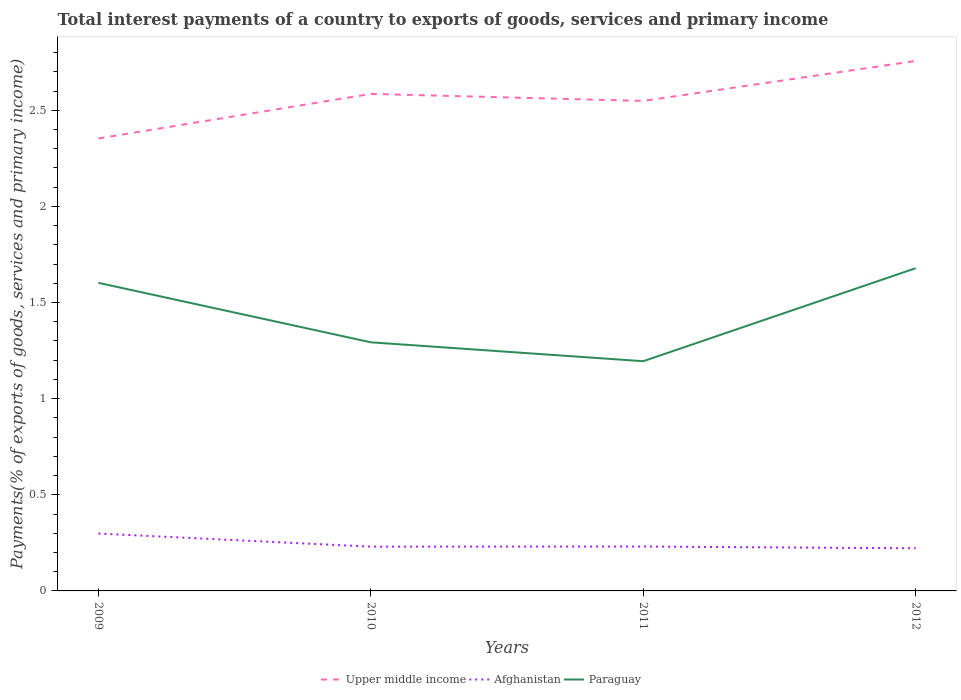Does the line corresponding to Afghanistan intersect with the line corresponding to Upper middle income?
Provide a succinct answer. No. Across all years, what is the maximum total interest payments in Paraguay?
Provide a succinct answer. 1.19. In which year was the total interest payments in Afghanistan maximum?
Provide a succinct answer. 2012. What is the total total interest payments in Upper middle income in the graph?
Provide a succinct answer. -0.17. What is the difference between the highest and the second highest total interest payments in Paraguay?
Your answer should be compact. 0.48. Is the total interest payments in Paraguay strictly greater than the total interest payments in Afghanistan over the years?
Your response must be concise. No. How many lines are there?
Ensure brevity in your answer.  3. What is the difference between two consecutive major ticks on the Y-axis?
Provide a succinct answer. 0.5. Are the values on the major ticks of Y-axis written in scientific E-notation?
Offer a very short reply. No. How are the legend labels stacked?
Your answer should be very brief. Horizontal. What is the title of the graph?
Provide a succinct answer. Total interest payments of a country to exports of goods, services and primary income. What is the label or title of the Y-axis?
Provide a short and direct response. Payments(% of exports of goods, services and primary income). What is the Payments(% of exports of goods, services and primary income) of Upper middle income in 2009?
Give a very brief answer. 2.35. What is the Payments(% of exports of goods, services and primary income) in Afghanistan in 2009?
Offer a terse response. 0.3. What is the Payments(% of exports of goods, services and primary income) of Paraguay in 2009?
Your response must be concise. 1.6. What is the Payments(% of exports of goods, services and primary income) in Upper middle income in 2010?
Offer a terse response. 2.59. What is the Payments(% of exports of goods, services and primary income) of Afghanistan in 2010?
Provide a succinct answer. 0.23. What is the Payments(% of exports of goods, services and primary income) of Paraguay in 2010?
Provide a succinct answer. 1.29. What is the Payments(% of exports of goods, services and primary income) in Upper middle income in 2011?
Ensure brevity in your answer.  2.55. What is the Payments(% of exports of goods, services and primary income) in Afghanistan in 2011?
Provide a succinct answer. 0.23. What is the Payments(% of exports of goods, services and primary income) in Paraguay in 2011?
Make the answer very short. 1.19. What is the Payments(% of exports of goods, services and primary income) of Upper middle income in 2012?
Provide a short and direct response. 2.76. What is the Payments(% of exports of goods, services and primary income) in Afghanistan in 2012?
Your answer should be very brief. 0.22. What is the Payments(% of exports of goods, services and primary income) of Paraguay in 2012?
Provide a short and direct response. 1.68. Across all years, what is the maximum Payments(% of exports of goods, services and primary income) of Upper middle income?
Offer a terse response. 2.76. Across all years, what is the maximum Payments(% of exports of goods, services and primary income) in Afghanistan?
Provide a short and direct response. 0.3. Across all years, what is the maximum Payments(% of exports of goods, services and primary income) in Paraguay?
Provide a succinct answer. 1.68. Across all years, what is the minimum Payments(% of exports of goods, services and primary income) in Upper middle income?
Your answer should be very brief. 2.35. Across all years, what is the minimum Payments(% of exports of goods, services and primary income) of Afghanistan?
Keep it short and to the point. 0.22. Across all years, what is the minimum Payments(% of exports of goods, services and primary income) in Paraguay?
Provide a succinct answer. 1.19. What is the total Payments(% of exports of goods, services and primary income) of Upper middle income in the graph?
Offer a terse response. 10.24. What is the total Payments(% of exports of goods, services and primary income) in Afghanistan in the graph?
Ensure brevity in your answer.  0.98. What is the total Payments(% of exports of goods, services and primary income) in Paraguay in the graph?
Your answer should be very brief. 5.77. What is the difference between the Payments(% of exports of goods, services and primary income) of Upper middle income in 2009 and that in 2010?
Provide a short and direct response. -0.23. What is the difference between the Payments(% of exports of goods, services and primary income) in Afghanistan in 2009 and that in 2010?
Offer a very short reply. 0.07. What is the difference between the Payments(% of exports of goods, services and primary income) of Paraguay in 2009 and that in 2010?
Offer a terse response. 0.31. What is the difference between the Payments(% of exports of goods, services and primary income) in Upper middle income in 2009 and that in 2011?
Offer a very short reply. -0.2. What is the difference between the Payments(% of exports of goods, services and primary income) of Afghanistan in 2009 and that in 2011?
Your answer should be compact. 0.07. What is the difference between the Payments(% of exports of goods, services and primary income) in Paraguay in 2009 and that in 2011?
Make the answer very short. 0.41. What is the difference between the Payments(% of exports of goods, services and primary income) in Upper middle income in 2009 and that in 2012?
Give a very brief answer. -0.4. What is the difference between the Payments(% of exports of goods, services and primary income) of Afghanistan in 2009 and that in 2012?
Make the answer very short. 0.08. What is the difference between the Payments(% of exports of goods, services and primary income) in Paraguay in 2009 and that in 2012?
Your answer should be compact. -0.08. What is the difference between the Payments(% of exports of goods, services and primary income) in Upper middle income in 2010 and that in 2011?
Make the answer very short. 0.04. What is the difference between the Payments(% of exports of goods, services and primary income) of Afghanistan in 2010 and that in 2011?
Offer a terse response. -0. What is the difference between the Payments(% of exports of goods, services and primary income) in Paraguay in 2010 and that in 2011?
Offer a terse response. 0.1. What is the difference between the Payments(% of exports of goods, services and primary income) of Upper middle income in 2010 and that in 2012?
Provide a succinct answer. -0.17. What is the difference between the Payments(% of exports of goods, services and primary income) in Afghanistan in 2010 and that in 2012?
Your response must be concise. 0.01. What is the difference between the Payments(% of exports of goods, services and primary income) of Paraguay in 2010 and that in 2012?
Your response must be concise. -0.39. What is the difference between the Payments(% of exports of goods, services and primary income) of Upper middle income in 2011 and that in 2012?
Provide a short and direct response. -0.21. What is the difference between the Payments(% of exports of goods, services and primary income) in Afghanistan in 2011 and that in 2012?
Offer a very short reply. 0.01. What is the difference between the Payments(% of exports of goods, services and primary income) of Paraguay in 2011 and that in 2012?
Provide a succinct answer. -0.48. What is the difference between the Payments(% of exports of goods, services and primary income) of Upper middle income in 2009 and the Payments(% of exports of goods, services and primary income) of Afghanistan in 2010?
Your answer should be compact. 2.12. What is the difference between the Payments(% of exports of goods, services and primary income) in Upper middle income in 2009 and the Payments(% of exports of goods, services and primary income) in Paraguay in 2010?
Ensure brevity in your answer.  1.06. What is the difference between the Payments(% of exports of goods, services and primary income) of Afghanistan in 2009 and the Payments(% of exports of goods, services and primary income) of Paraguay in 2010?
Your answer should be compact. -0.99. What is the difference between the Payments(% of exports of goods, services and primary income) of Upper middle income in 2009 and the Payments(% of exports of goods, services and primary income) of Afghanistan in 2011?
Provide a succinct answer. 2.12. What is the difference between the Payments(% of exports of goods, services and primary income) in Upper middle income in 2009 and the Payments(% of exports of goods, services and primary income) in Paraguay in 2011?
Make the answer very short. 1.16. What is the difference between the Payments(% of exports of goods, services and primary income) of Afghanistan in 2009 and the Payments(% of exports of goods, services and primary income) of Paraguay in 2011?
Provide a succinct answer. -0.9. What is the difference between the Payments(% of exports of goods, services and primary income) in Upper middle income in 2009 and the Payments(% of exports of goods, services and primary income) in Afghanistan in 2012?
Offer a terse response. 2.13. What is the difference between the Payments(% of exports of goods, services and primary income) in Upper middle income in 2009 and the Payments(% of exports of goods, services and primary income) in Paraguay in 2012?
Offer a very short reply. 0.67. What is the difference between the Payments(% of exports of goods, services and primary income) of Afghanistan in 2009 and the Payments(% of exports of goods, services and primary income) of Paraguay in 2012?
Give a very brief answer. -1.38. What is the difference between the Payments(% of exports of goods, services and primary income) in Upper middle income in 2010 and the Payments(% of exports of goods, services and primary income) in Afghanistan in 2011?
Offer a very short reply. 2.35. What is the difference between the Payments(% of exports of goods, services and primary income) in Upper middle income in 2010 and the Payments(% of exports of goods, services and primary income) in Paraguay in 2011?
Offer a terse response. 1.39. What is the difference between the Payments(% of exports of goods, services and primary income) in Afghanistan in 2010 and the Payments(% of exports of goods, services and primary income) in Paraguay in 2011?
Your response must be concise. -0.96. What is the difference between the Payments(% of exports of goods, services and primary income) of Upper middle income in 2010 and the Payments(% of exports of goods, services and primary income) of Afghanistan in 2012?
Your response must be concise. 2.36. What is the difference between the Payments(% of exports of goods, services and primary income) of Upper middle income in 2010 and the Payments(% of exports of goods, services and primary income) of Paraguay in 2012?
Give a very brief answer. 0.91. What is the difference between the Payments(% of exports of goods, services and primary income) in Afghanistan in 2010 and the Payments(% of exports of goods, services and primary income) in Paraguay in 2012?
Give a very brief answer. -1.45. What is the difference between the Payments(% of exports of goods, services and primary income) of Upper middle income in 2011 and the Payments(% of exports of goods, services and primary income) of Afghanistan in 2012?
Keep it short and to the point. 2.33. What is the difference between the Payments(% of exports of goods, services and primary income) in Upper middle income in 2011 and the Payments(% of exports of goods, services and primary income) in Paraguay in 2012?
Your answer should be compact. 0.87. What is the difference between the Payments(% of exports of goods, services and primary income) of Afghanistan in 2011 and the Payments(% of exports of goods, services and primary income) of Paraguay in 2012?
Provide a short and direct response. -1.45. What is the average Payments(% of exports of goods, services and primary income) of Upper middle income per year?
Offer a terse response. 2.56. What is the average Payments(% of exports of goods, services and primary income) in Afghanistan per year?
Your answer should be very brief. 0.25. What is the average Payments(% of exports of goods, services and primary income) in Paraguay per year?
Your answer should be compact. 1.44. In the year 2009, what is the difference between the Payments(% of exports of goods, services and primary income) of Upper middle income and Payments(% of exports of goods, services and primary income) of Afghanistan?
Provide a short and direct response. 2.05. In the year 2009, what is the difference between the Payments(% of exports of goods, services and primary income) in Upper middle income and Payments(% of exports of goods, services and primary income) in Paraguay?
Provide a short and direct response. 0.75. In the year 2009, what is the difference between the Payments(% of exports of goods, services and primary income) of Afghanistan and Payments(% of exports of goods, services and primary income) of Paraguay?
Offer a very short reply. -1.3. In the year 2010, what is the difference between the Payments(% of exports of goods, services and primary income) of Upper middle income and Payments(% of exports of goods, services and primary income) of Afghanistan?
Offer a very short reply. 2.35. In the year 2010, what is the difference between the Payments(% of exports of goods, services and primary income) in Upper middle income and Payments(% of exports of goods, services and primary income) in Paraguay?
Give a very brief answer. 1.29. In the year 2010, what is the difference between the Payments(% of exports of goods, services and primary income) in Afghanistan and Payments(% of exports of goods, services and primary income) in Paraguay?
Your answer should be compact. -1.06. In the year 2011, what is the difference between the Payments(% of exports of goods, services and primary income) in Upper middle income and Payments(% of exports of goods, services and primary income) in Afghanistan?
Offer a very short reply. 2.32. In the year 2011, what is the difference between the Payments(% of exports of goods, services and primary income) in Upper middle income and Payments(% of exports of goods, services and primary income) in Paraguay?
Your answer should be compact. 1.35. In the year 2011, what is the difference between the Payments(% of exports of goods, services and primary income) of Afghanistan and Payments(% of exports of goods, services and primary income) of Paraguay?
Your answer should be compact. -0.96. In the year 2012, what is the difference between the Payments(% of exports of goods, services and primary income) in Upper middle income and Payments(% of exports of goods, services and primary income) in Afghanistan?
Ensure brevity in your answer.  2.53. In the year 2012, what is the difference between the Payments(% of exports of goods, services and primary income) of Upper middle income and Payments(% of exports of goods, services and primary income) of Paraguay?
Give a very brief answer. 1.08. In the year 2012, what is the difference between the Payments(% of exports of goods, services and primary income) of Afghanistan and Payments(% of exports of goods, services and primary income) of Paraguay?
Your answer should be compact. -1.46. What is the ratio of the Payments(% of exports of goods, services and primary income) in Upper middle income in 2009 to that in 2010?
Provide a succinct answer. 0.91. What is the ratio of the Payments(% of exports of goods, services and primary income) in Afghanistan in 2009 to that in 2010?
Provide a short and direct response. 1.3. What is the ratio of the Payments(% of exports of goods, services and primary income) in Paraguay in 2009 to that in 2010?
Keep it short and to the point. 1.24. What is the ratio of the Payments(% of exports of goods, services and primary income) in Upper middle income in 2009 to that in 2011?
Your answer should be very brief. 0.92. What is the ratio of the Payments(% of exports of goods, services and primary income) in Afghanistan in 2009 to that in 2011?
Offer a terse response. 1.29. What is the ratio of the Payments(% of exports of goods, services and primary income) in Paraguay in 2009 to that in 2011?
Your response must be concise. 1.34. What is the ratio of the Payments(% of exports of goods, services and primary income) in Upper middle income in 2009 to that in 2012?
Offer a terse response. 0.85. What is the ratio of the Payments(% of exports of goods, services and primary income) in Afghanistan in 2009 to that in 2012?
Ensure brevity in your answer.  1.35. What is the ratio of the Payments(% of exports of goods, services and primary income) of Paraguay in 2009 to that in 2012?
Your answer should be very brief. 0.95. What is the ratio of the Payments(% of exports of goods, services and primary income) in Upper middle income in 2010 to that in 2011?
Offer a very short reply. 1.01. What is the ratio of the Payments(% of exports of goods, services and primary income) in Afghanistan in 2010 to that in 2011?
Offer a very short reply. 1. What is the ratio of the Payments(% of exports of goods, services and primary income) of Paraguay in 2010 to that in 2011?
Your answer should be compact. 1.08. What is the ratio of the Payments(% of exports of goods, services and primary income) of Upper middle income in 2010 to that in 2012?
Offer a terse response. 0.94. What is the ratio of the Payments(% of exports of goods, services and primary income) of Afghanistan in 2010 to that in 2012?
Offer a terse response. 1.04. What is the ratio of the Payments(% of exports of goods, services and primary income) in Paraguay in 2010 to that in 2012?
Your answer should be very brief. 0.77. What is the ratio of the Payments(% of exports of goods, services and primary income) of Upper middle income in 2011 to that in 2012?
Keep it short and to the point. 0.92. What is the ratio of the Payments(% of exports of goods, services and primary income) of Afghanistan in 2011 to that in 2012?
Keep it short and to the point. 1.04. What is the ratio of the Payments(% of exports of goods, services and primary income) of Paraguay in 2011 to that in 2012?
Offer a terse response. 0.71. What is the difference between the highest and the second highest Payments(% of exports of goods, services and primary income) in Upper middle income?
Provide a succinct answer. 0.17. What is the difference between the highest and the second highest Payments(% of exports of goods, services and primary income) in Afghanistan?
Make the answer very short. 0.07. What is the difference between the highest and the second highest Payments(% of exports of goods, services and primary income) of Paraguay?
Provide a short and direct response. 0.08. What is the difference between the highest and the lowest Payments(% of exports of goods, services and primary income) of Upper middle income?
Provide a short and direct response. 0.4. What is the difference between the highest and the lowest Payments(% of exports of goods, services and primary income) in Afghanistan?
Your answer should be compact. 0.08. What is the difference between the highest and the lowest Payments(% of exports of goods, services and primary income) in Paraguay?
Your answer should be compact. 0.48. 